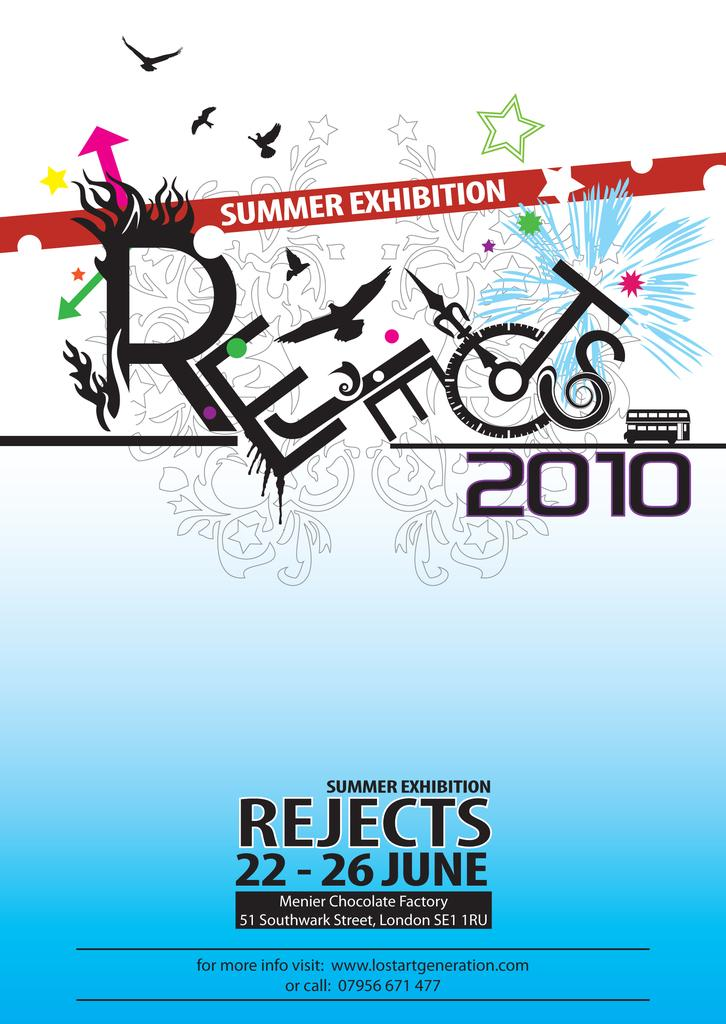Provide a one-sentence caption for the provided image. An advertisement for a summer exhibition called Rejects 2010 will run from June 22-26. 